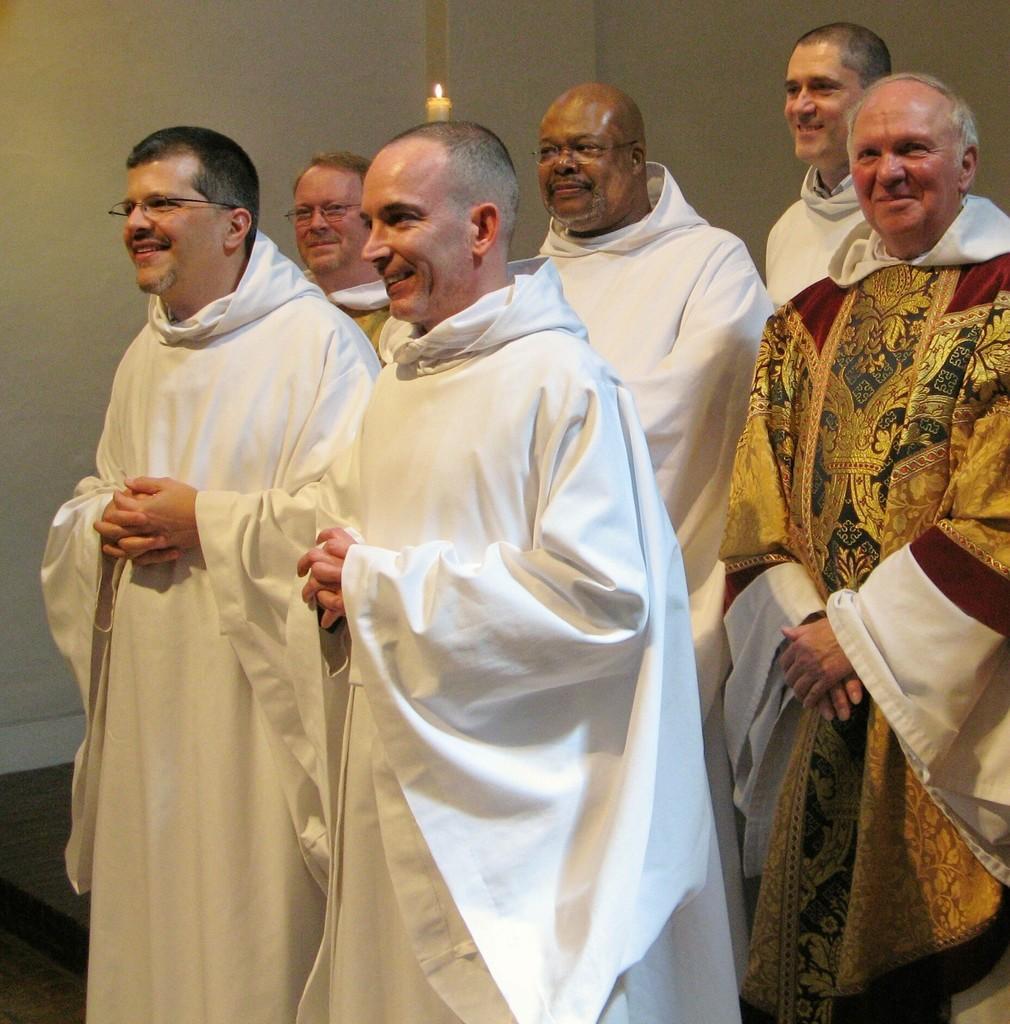Could you give a brief overview of what you see in this image? This picture seems to be clicked inside the room. In the foreground we can see the group of persons wearing dresses, smiling and standing. In the background we can see the wall and a burning candle. 